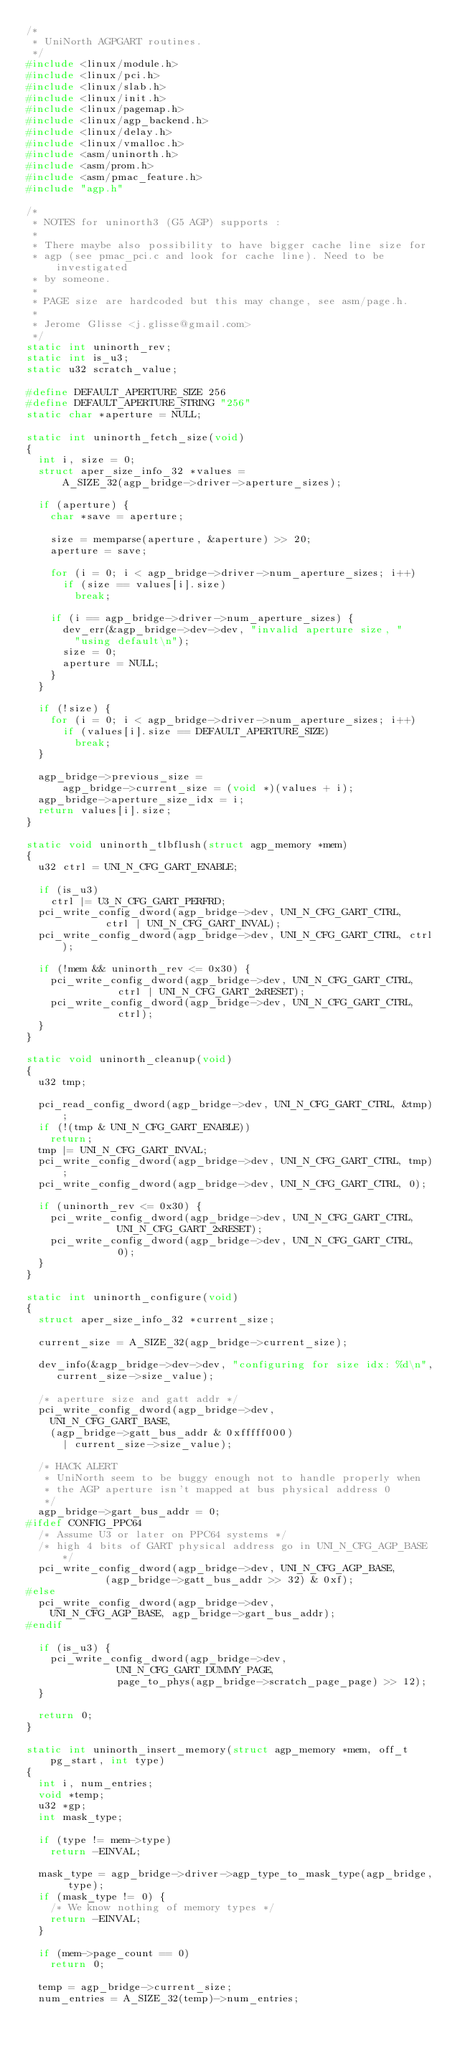Convert code to text. <code><loc_0><loc_0><loc_500><loc_500><_C_>/*
 * UniNorth AGPGART routines.
 */
#include <linux/module.h>
#include <linux/pci.h>
#include <linux/slab.h>
#include <linux/init.h>
#include <linux/pagemap.h>
#include <linux/agp_backend.h>
#include <linux/delay.h>
#include <linux/vmalloc.h>
#include <asm/uninorth.h>
#include <asm/prom.h>
#include <asm/pmac_feature.h>
#include "agp.h"

/*
 * NOTES for uninorth3 (G5 AGP) supports :
 *
 * There maybe also possibility to have bigger cache line size for
 * agp (see pmac_pci.c and look for cache line). Need to be investigated
 * by someone.
 *
 * PAGE size are hardcoded but this may change, see asm/page.h.
 *
 * Jerome Glisse <j.glisse@gmail.com>
 */
static int uninorth_rev;
static int is_u3;
static u32 scratch_value;

#define DEFAULT_APERTURE_SIZE 256
#define DEFAULT_APERTURE_STRING "256"
static char *aperture = NULL;

static int uninorth_fetch_size(void)
{
	int i, size = 0;
	struct aper_size_info_32 *values =
	    A_SIZE_32(agp_bridge->driver->aperture_sizes);

	if (aperture) {
		char *save = aperture;

		size = memparse(aperture, &aperture) >> 20;
		aperture = save;

		for (i = 0; i < agp_bridge->driver->num_aperture_sizes; i++)
			if (size == values[i].size)
				break;

		if (i == agp_bridge->driver->num_aperture_sizes) {
			dev_err(&agp_bridge->dev->dev, "invalid aperture size, "
				"using default\n");
			size = 0;
			aperture = NULL;
		}
	}

	if (!size) {
		for (i = 0; i < agp_bridge->driver->num_aperture_sizes; i++)
			if (values[i].size == DEFAULT_APERTURE_SIZE)
				break;
	}

	agp_bridge->previous_size =
	    agp_bridge->current_size = (void *)(values + i);
	agp_bridge->aperture_size_idx = i;
	return values[i].size;
}

static void uninorth_tlbflush(struct agp_memory *mem)
{
	u32 ctrl = UNI_N_CFG_GART_ENABLE;

	if (is_u3)
		ctrl |= U3_N_CFG_GART_PERFRD;
	pci_write_config_dword(agp_bridge->dev, UNI_N_CFG_GART_CTRL,
			       ctrl | UNI_N_CFG_GART_INVAL);
	pci_write_config_dword(agp_bridge->dev, UNI_N_CFG_GART_CTRL, ctrl);

	if (!mem && uninorth_rev <= 0x30) {
		pci_write_config_dword(agp_bridge->dev, UNI_N_CFG_GART_CTRL,
				       ctrl | UNI_N_CFG_GART_2xRESET);
		pci_write_config_dword(agp_bridge->dev, UNI_N_CFG_GART_CTRL,
				       ctrl);
	}
}

static void uninorth_cleanup(void)
{
	u32 tmp;

	pci_read_config_dword(agp_bridge->dev, UNI_N_CFG_GART_CTRL, &tmp);
	if (!(tmp & UNI_N_CFG_GART_ENABLE))
		return;
	tmp |= UNI_N_CFG_GART_INVAL;
	pci_write_config_dword(agp_bridge->dev, UNI_N_CFG_GART_CTRL, tmp);
	pci_write_config_dword(agp_bridge->dev, UNI_N_CFG_GART_CTRL, 0);

	if (uninorth_rev <= 0x30) {
		pci_write_config_dword(agp_bridge->dev, UNI_N_CFG_GART_CTRL,
				       UNI_N_CFG_GART_2xRESET);
		pci_write_config_dword(agp_bridge->dev, UNI_N_CFG_GART_CTRL,
				       0);
	}
}

static int uninorth_configure(void)
{
	struct aper_size_info_32 *current_size;

	current_size = A_SIZE_32(agp_bridge->current_size);

	dev_info(&agp_bridge->dev->dev, "configuring for size idx: %d\n",
		 current_size->size_value);

	/* aperture size and gatt addr */
	pci_write_config_dword(agp_bridge->dev,
		UNI_N_CFG_GART_BASE,
		(agp_bridge->gatt_bus_addr & 0xfffff000)
			| current_size->size_value);

	/* HACK ALERT
	 * UniNorth seem to be buggy enough not to handle properly when
	 * the AGP aperture isn't mapped at bus physical address 0
	 */
	agp_bridge->gart_bus_addr = 0;
#ifdef CONFIG_PPC64
	/* Assume U3 or later on PPC64 systems */
	/* high 4 bits of GART physical address go in UNI_N_CFG_AGP_BASE */
	pci_write_config_dword(agp_bridge->dev, UNI_N_CFG_AGP_BASE,
			       (agp_bridge->gatt_bus_addr >> 32) & 0xf);
#else
	pci_write_config_dword(agp_bridge->dev,
		UNI_N_CFG_AGP_BASE, agp_bridge->gart_bus_addr);
#endif

	if (is_u3) {
		pci_write_config_dword(agp_bridge->dev,
				       UNI_N_CFG_GART_DUMMY_PAGE,
				       page_to_phys(agp_bridge->scratch_page_page) >> 12);
	}

	return 0;
}

static int uninorth_insert_memory(struct agp_memory *mem, off_t pg_start, int type)
{
	int i, num_entries;
	void *temp;
	u32 *gp;
	int mask_type;

	if (type != mem->type)
		return -EINVAL;

	mask_type = agp_bridge->driver->agp_type_to_mask_type(agp_bridge, type);
	if (mask_type != 0) {
		/* We know nothing of memory types */
		return -EINVAL;
	}

	if (mem->page_count == 0)
		return 0;

	temp = agp_bridge->current_size;
	num_entries = A_SIZE_32(temp)->num_entries;
</code> 